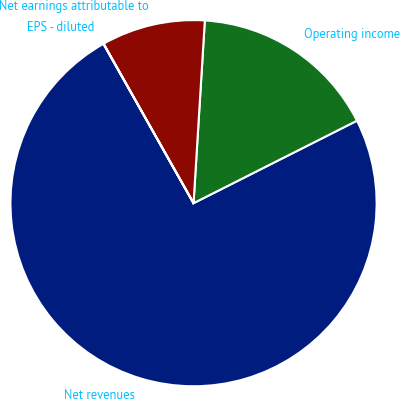<chart> <loc_0><loc_0><loc_500><loc_500><pie_chart><fcel>Net revenues<fcel>Operating income<fcel>Net earnings attributable to<fcel>EPS - diluted<nl><fcel>74.26%<fcel>16.58%<fcel>9.16%<fcel>0.01%<nl></chart> 